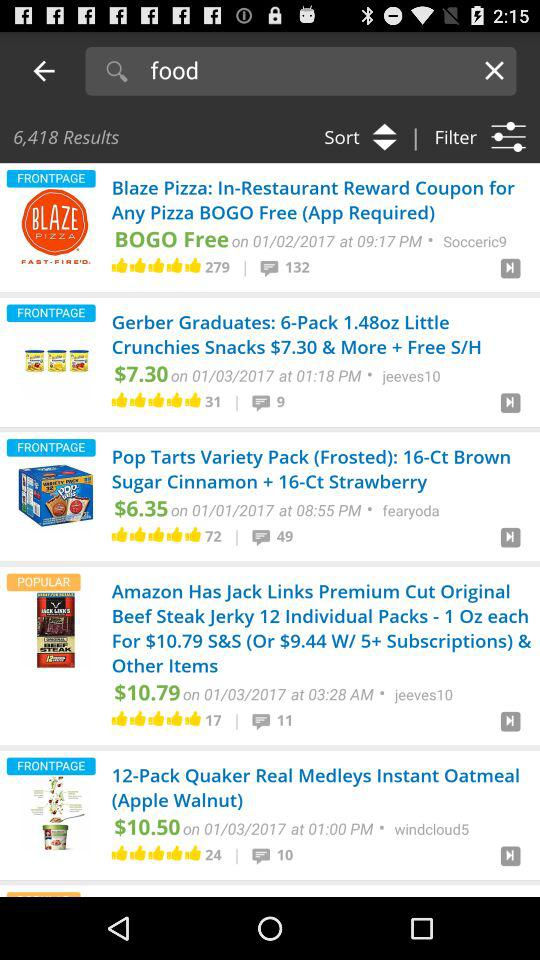How many results are there for the search query "food"?
Answer the question using a single word or phrase. 6,418 